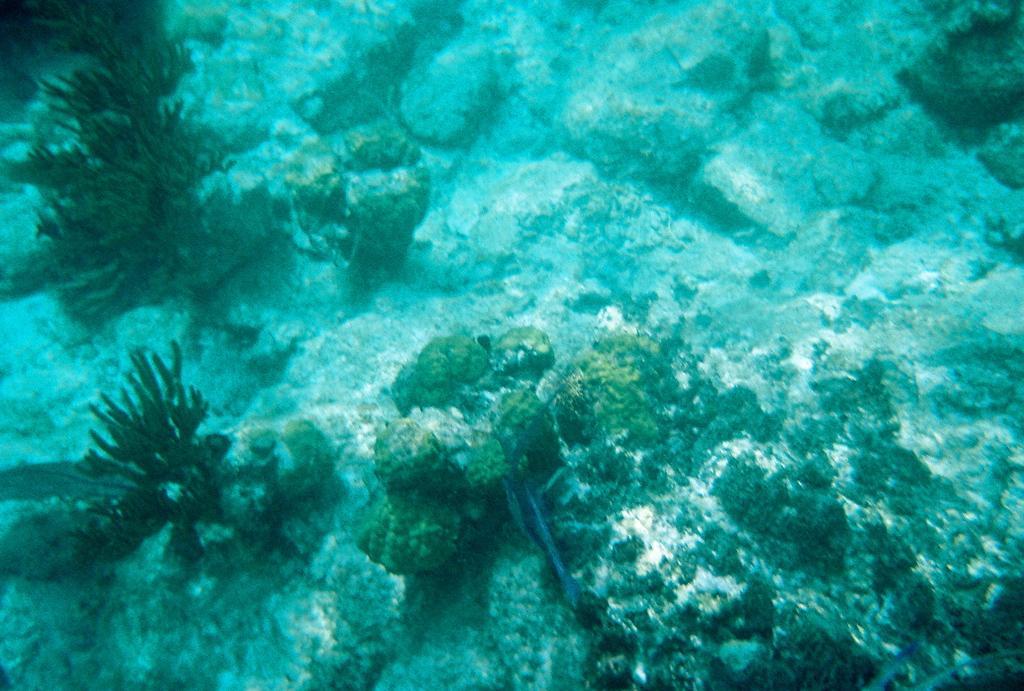Could you give a brief overview of what you see in this image? In the image we can see water marines. Here we can see water plants and stones. 